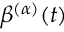Convert formula to latex. <formula><loc_0><loc_0><loc_500><loc_500>\beta ^ { ( \alpha ) } ( t )</formula> 